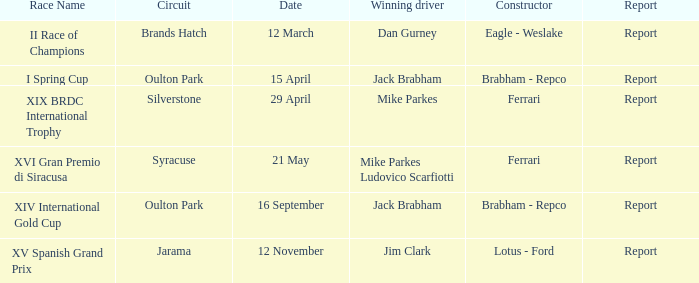What is the identity of the race on 16 september? XIV International Gold Cup. 